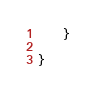Convert code to text. <code><loc_0><loc_0><loc_500><loc_500><_Java_>    }

}
</code> 